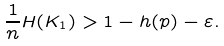Convert formula to latex. <formula><loc_0><loc_0><loc_500><loc_500>\frac { 1 } { n } H ( K _ { 1 } ) > 1 - h ( p ) - \varepsilon .</formula> 